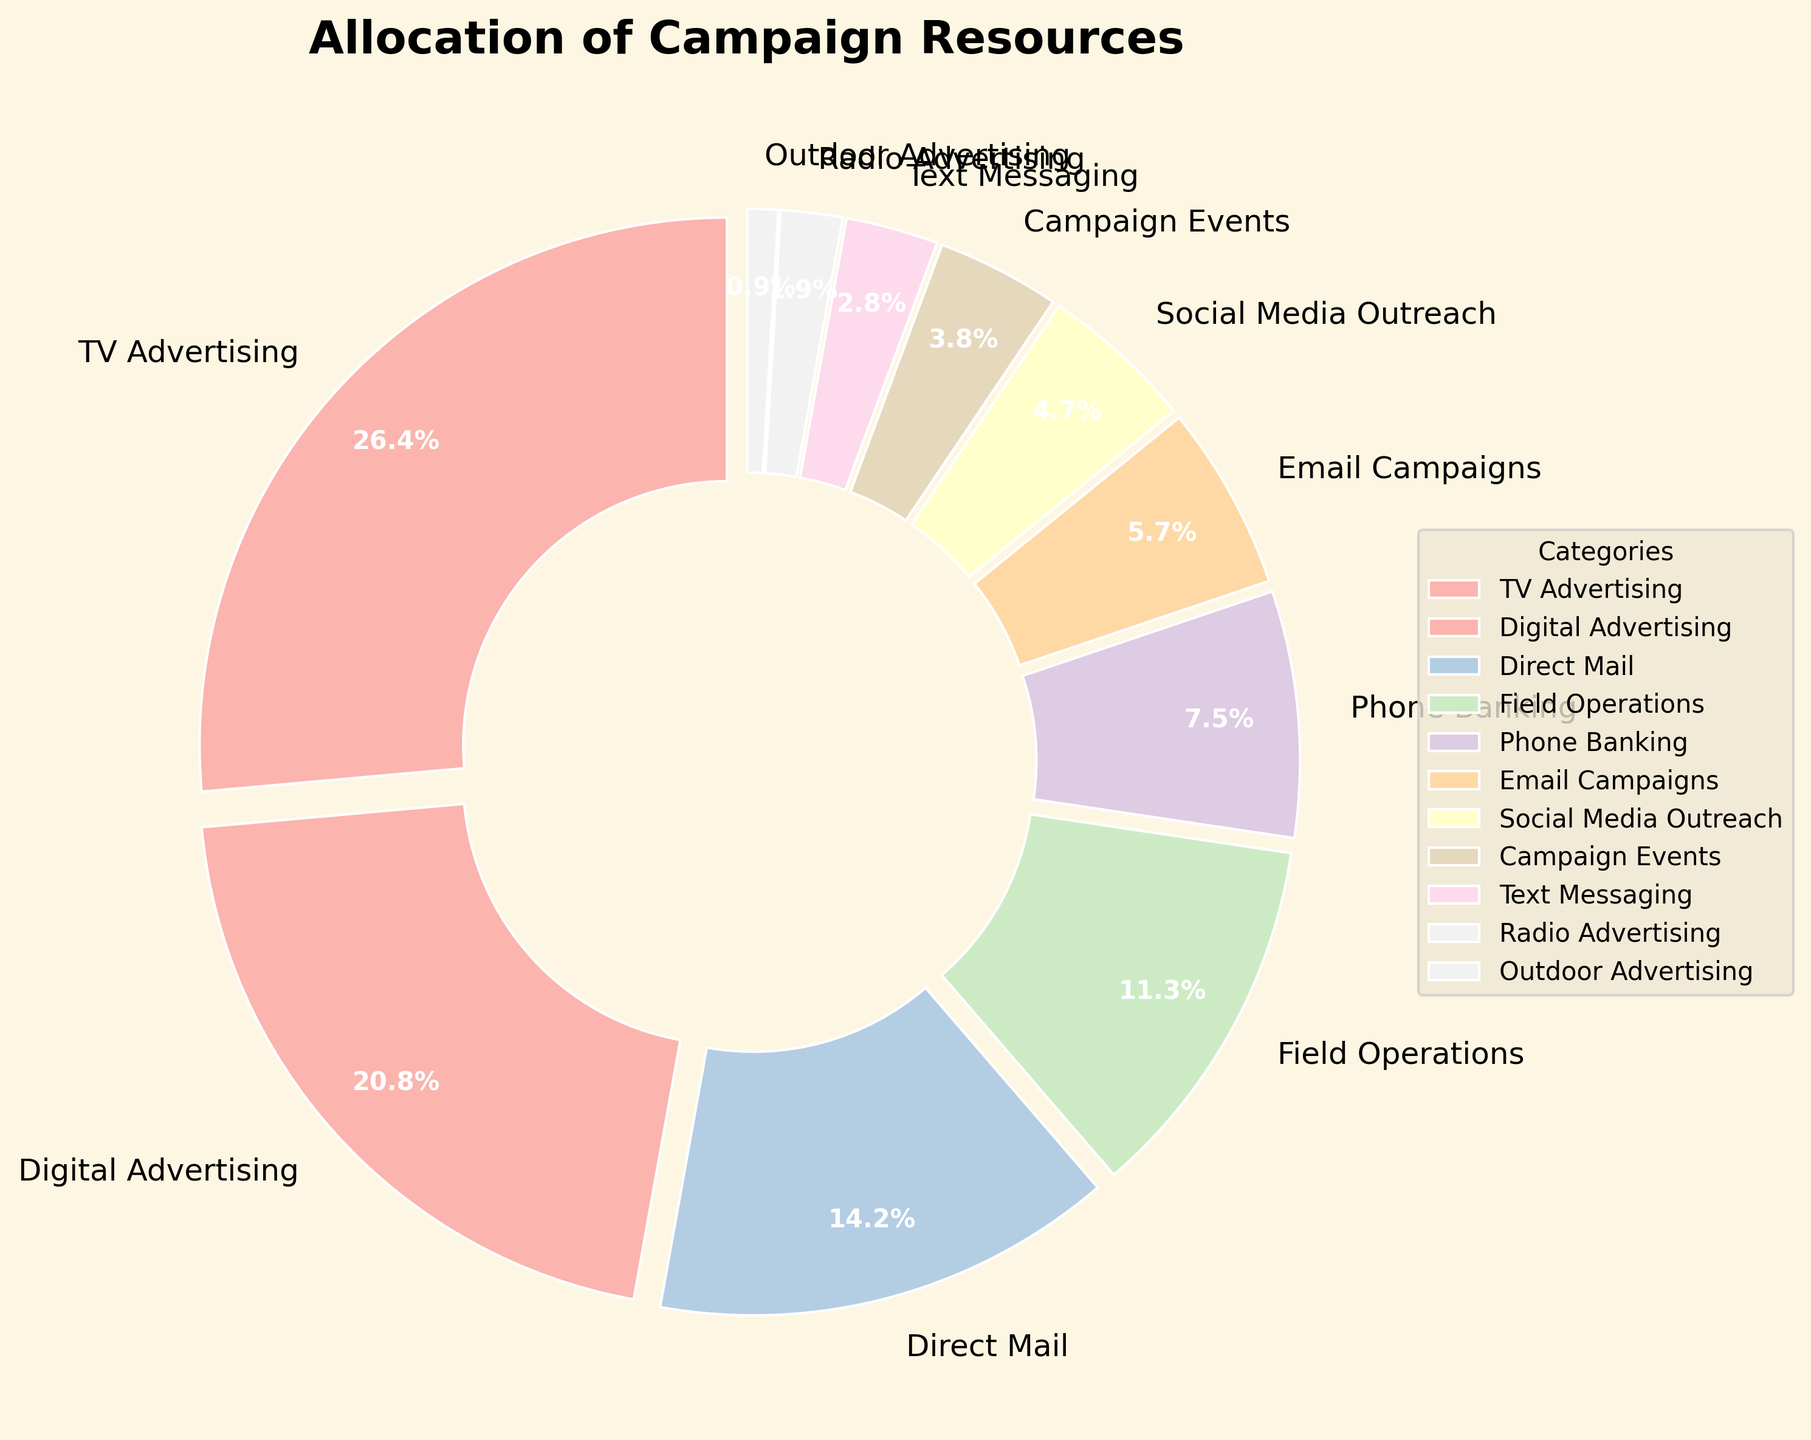What is the total percentage allocation for TV and Digital Advertising combined? To find this, add the percentage allocation for TV Advertising (28%) and Digital Advertising (22%). Therefore, 28% + 22% = 50%.
Answer: 50% Which outreach method has the smallest allocation percentage? By examining the pie chart, we see that Outdoor Advertising has the smallest allocation percentage of 1%.
Answer: Outdoor Advertising What is the difference in percentage between Field Operations and Phone Banking? Field Operations has 12%, and Phone Banking has 8%. To find the difference, subtract 8% from 12%, which is 4%.
Answer: 4% How many categories have an allocation of less than 10%? By looking at the chart, we see that Phone Banking (8%), Email Campaigns (6%), Social Media Outreach (5%), Campaign Events (4%), Text Messaging (3%), Radio Advertising (2%), and Outdoor Advertising (1%) all have percentages less than 10%. This makes 7 categories.
Answer: 7 Which category occupies more space: Email Campaigns or Social Media Outreach? By observing the wedge sizes, we see that Email Campaigns (6%) has a larger allocation than Social Media Outreach (5%).
Answer: Email Campaigns What is the combined percentage for all categories that have less than 5% allocation? Social Media Outreach (5%), Campaign Events (4%), Text Messaging (3%), Radio Advertising (2%), and Outdoor Advertising (1%) all have less than 5% allocation. Summing them up: 5% + 4% + 3% + 2% + 1% = 15%.
Answer: 15% Which method of outreach has the second highest allocation percentage? From the pie chart, the second highest allocation percentage is Digital Advertising, which is 22%.
Answer: Digital Advertising How does the percentage allocation for Direct Mail compare to that for Field Operations? Direct Mail has 15%, and Field Operations has 12%. Direct Mail has a greater allocation than Field Operations.
Answer: Direct Mail has a greater allocation Is the allocation for Campaign Events more or less than half of the allocation for Direct Mail? Campaign Events have 4%, and Direct Mail has 15%. Half of Direct Mail's 15% is 7.5%. Since 4% is less than 7.5%, Campaign Events have less than half of Direct Mail's allocation.
Answer: Less 